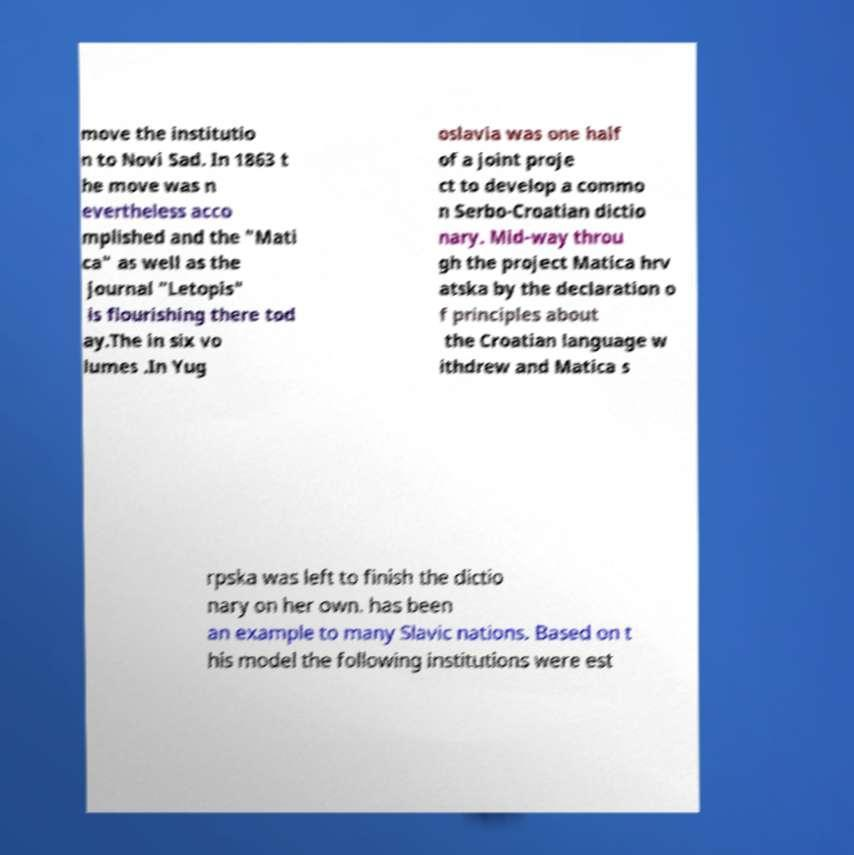Can you accurately transcribe the text from the provided image for me? move the institutio n to Novi Sad. In 1863 t he move was n evertheless acco mplished and the "Mati ca" as well as the journal "Letopis" is flourishing there tod ay.The in six vo lumes .In Yug oslavia was one half of a joint proje ct to develop a commo n Serbo-Croatian dictio nary. Mid-way throu gh the project Matica hrv atska by the declaration o f principles about the Croatian language w ithdrew and Matica s rpska was left to finish the dictio nary on her own. has been an example to many Slavic nations. Based on t his model the following institutions were est 